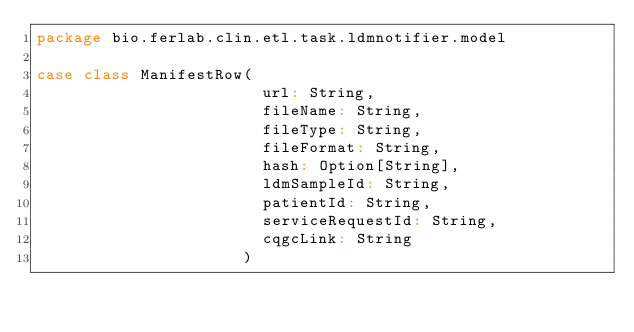Convert code to text. <code><loc_0><loc_0><loc_500><loc_500><_Scala_>package bio.ferlab.clin.etl.task.ldmnotifier.model

case class ManifestRow(
                        url: String,
                        fileName: String,
                        fileType: String,
                        fileFormat: String,
                        hash: Option[String],
                        ldmSampleId: String,
                        patientId: String,
                        serviceRequestId: String,
                        cqgcLink: String
                      )</code> 